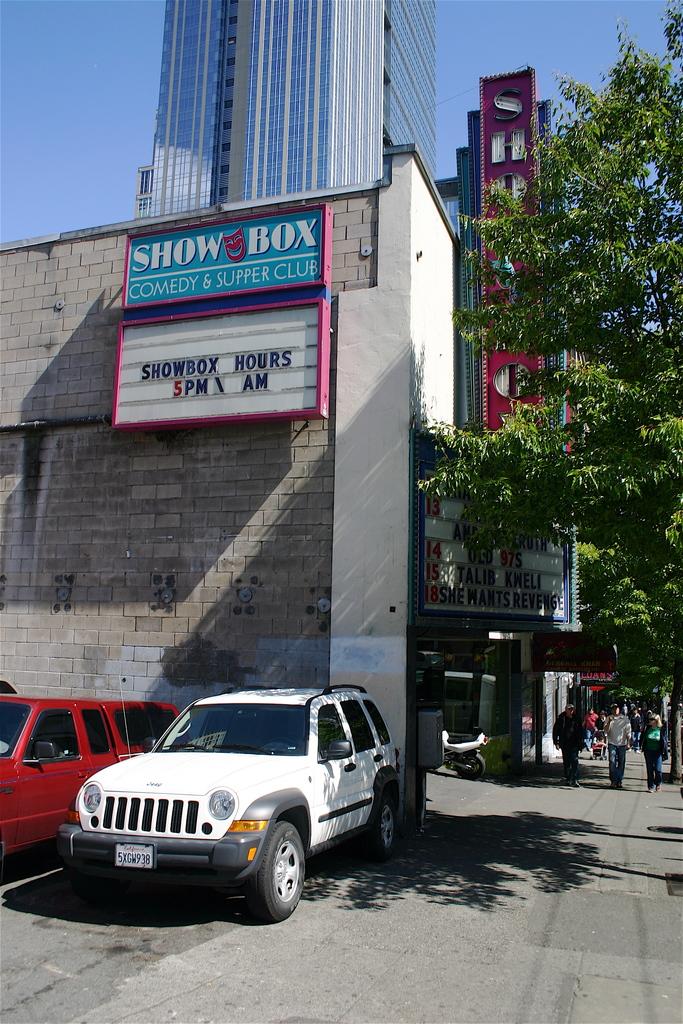Are the showbox hours missing a.m. hours?
Offer a terse response. Yes. What is this movie theater called?
Your answer should be very brief. Show box. 